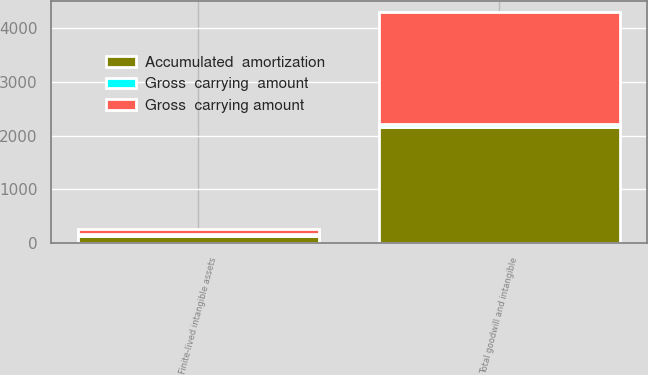Convert chart. <chart><loc_0><loc_0><loc_500><loc_500><stacked_bar_chart><ecel><fcel>Finite-lived intangible assets<fcel>Total goodwill and intangible<nl><fcel>Accumulated  amortization<fcel>131<fcel>2171.5<nl><fcel>Gross  carrying  amount<fcel>40.1<fcel>40.1<nl><fcel>Gross  carrying amount<fcel>94.7<fcel>2087.7<nl></chart> 